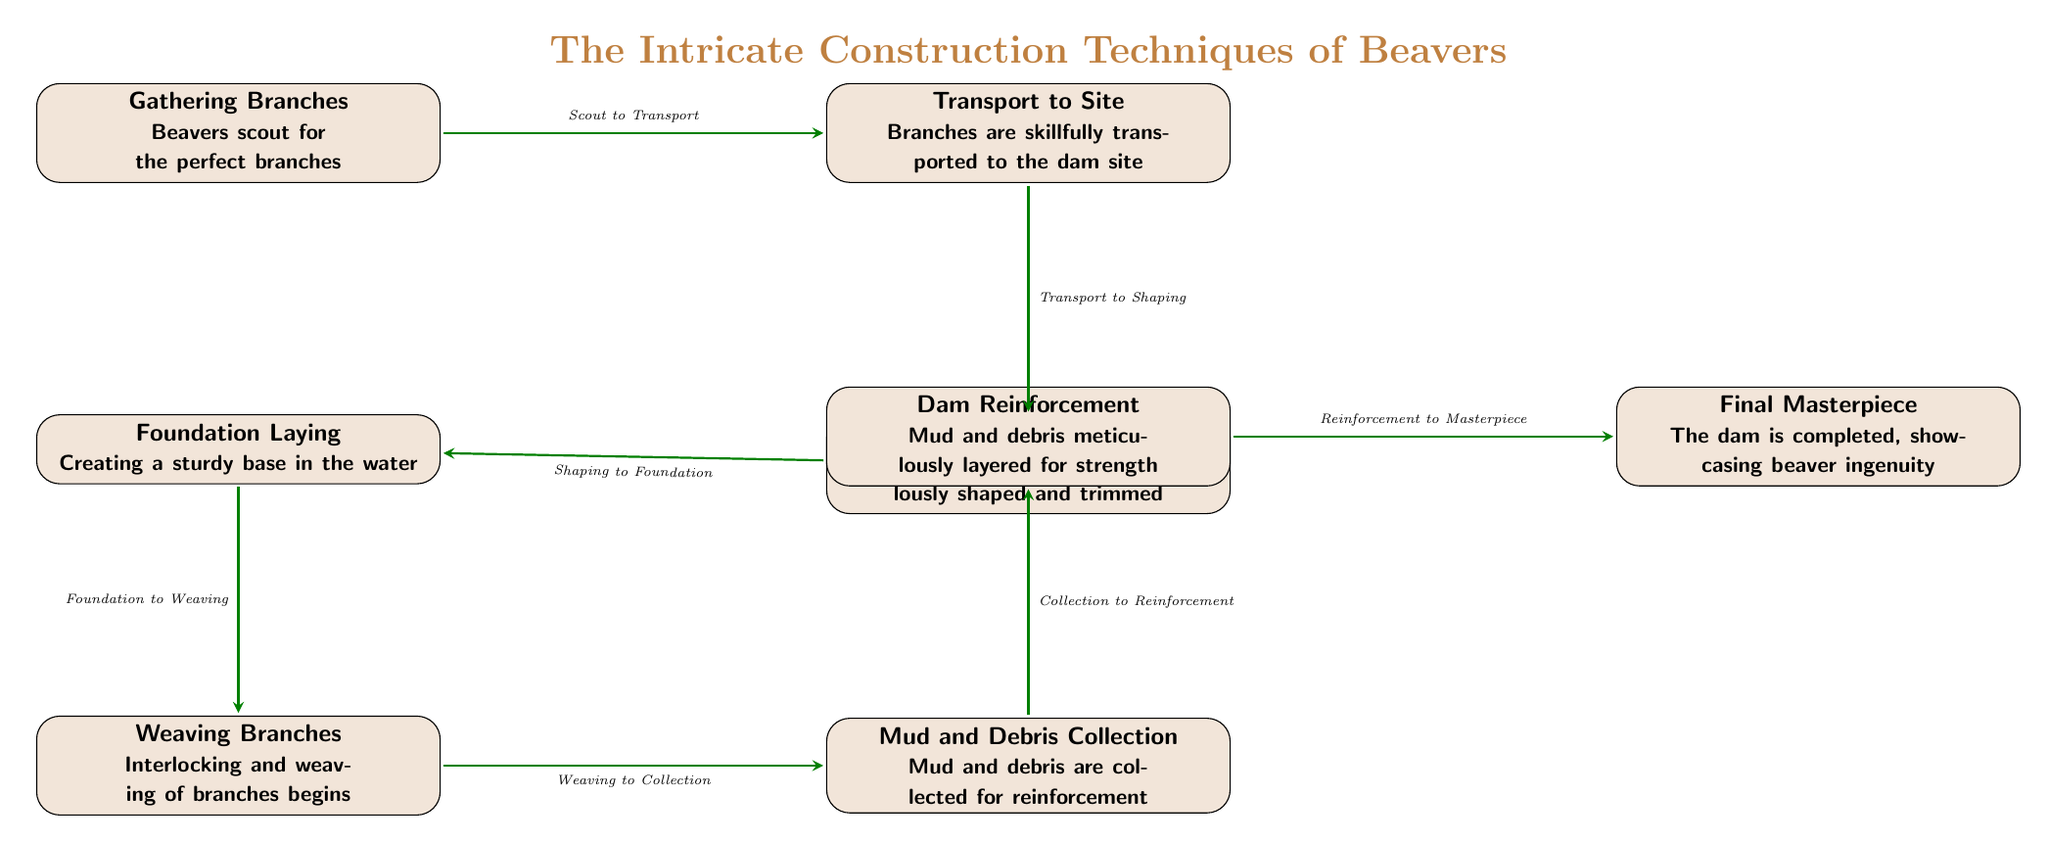What is the first step in dam construction? The diagram indicates that the first step is "Gathering Branches", which is depicted as the initial node in the flow of beaver dam construction.
Answer: Gathering Branches How many total steps are shown in the diagram? By counting the nodes from "Gathering Branches" to "Final Masterpiece", we find there are a total of 8 steps displayed in the diagram.
Answer: 8 What comes immediately after "Weaving Branches"? Referring to the edges in the diagram, the immediate step that follows "Weaving Branches" is "Mud and Debris Collection", as indicated by the directed edge connecting these two nodes.
Answer: Mud and Debris Collection What is the purpose of “Mud and Debris Collection”? In the diagram, "Mud and Debris Collection" is described as an effort to gather materials that reinforce the dam, as shown in the explanatory text associated with that node.
Answer: Reinforcement What is the relationship between “Foundation Laying” and “Weaving Branches”? The relationship is that "Foundation Laying" occurs before "Weaving Branches", as indicated by the directed edge in the diagram leading from the former to the latter, which shows the sequential order in dam construction.
Answer: Before Which step showcases the final result of beaver ingenuity? The step that showcases the final result is "Final Masterpiece", as noted at the end of the construction process in the flow of the diagram.
Answer: Final Masterpiece What type of material is layered for strength during dam reinforcement? The diagram explicitly states that "Mud and debris" are the materials that are meticulously layered for strength in the section labeled "Dam Reinforcement".
Answer: Mud and Debris How is the beaver’s construction process defined in terms of structure? The structure of the beaver's construction process is defined by a sequential flowchart layout, which illustrates the step-by-step progression from initial gathering to the completed dam.
Answer: Flowchart Layout 